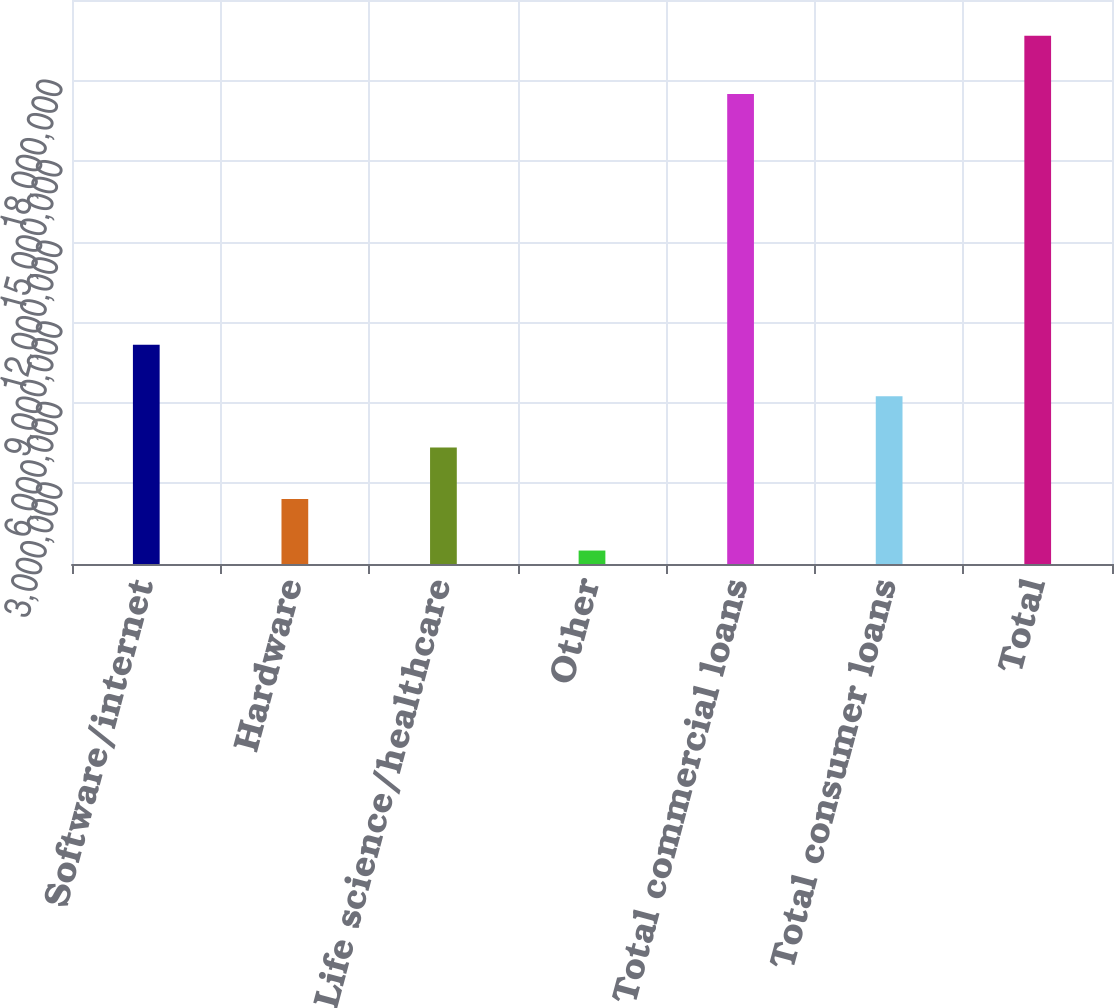Convert chart. <chart><loc_0><loc_0><loc_500><loc_500><bar_chart><fcel>Software/internet<fcel>Hardware<fcel>Life science/healthcare<fcel>Other<fcel>Total commercial loans<fcel>Total consumer loans<fcel>Total<nl><fcel>8.1667e+06<fcel>2.41731e+06<fcel>4.33377e+06<fcel>500842<fcel>1.75011e+07<fcel>6.25023e+06<fcel>1.96655e+07<nl></chart> 